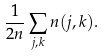<formula> <loc_0><loc_0><loc_500><loc_500>\frac { 1 } { 2 n } \sum _ { j , k } n ( j , k ) .</formula> 